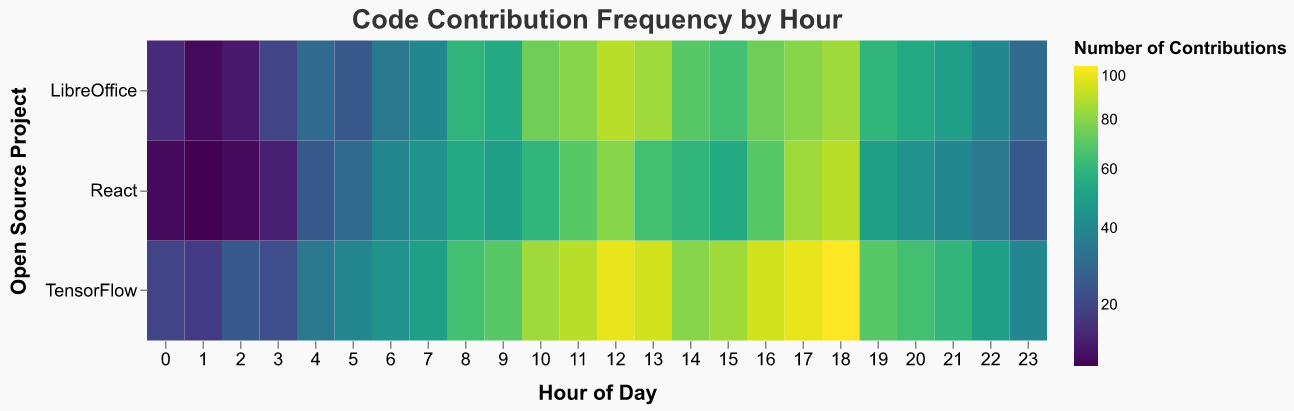What is the title of the heatmap? The title of the heatmap is displayed at the top of the visualization and generally provides an overview of what the chart represents.
Answer: Code Contribution Frequency by Hour Which project has the highest number of contributions at hour 12? To find this, locate hour 12 on the horizontal axis and compare the contributions for each project on the vertical axis. The color intensity helps identify the highest value.
Answer: TensorFlow At what hour does the React project have its peak number of contributions? Examine the row corresponding to 'React' by looking across different hours. Identify the hour with the most intense color, indicating the maximum contributions.
Answer: 18 How many data points are there in the heatmap? Each hour has an entry for all three projects, and there are 24 hours in a day. Multiply the number of projects by the number of hours. 3 projects * 24 hours = 72 data points.
Answer: 72 Which project tends to have the highest number of contributions throughout the day, on average? Compare the average color intensity across all hours for each project. The project with the most consistently intense colors will have the highest average contributions.
Answer: TensorFlow During which hours do all projects have relatively low contributions? Low contributions correspond to the least intense colors. Identify hours, such as early morning or late at night, where all projects show lower intensity colors.
Answer: 0-2 and 20-23 What is the difference in contributions for TensorFlow between hours 10 and 22? Find the contributions for TensorFlow at hour 10 (85) and at hour 22 (50). Calculate the difference: 85 - 50 = 35.
Answer: 35 Which hour has the highest combined contributions across all projects? Sum the contributions of all projects for each hour and identify the maximum sum. For example, hour 12 has contributions of LibreOffice (90) + TensorFlow (100) + React (80) = 270.
Answer: 12 Are there any hours where the contributions for all three projects are the same? Check all hours horizontally for uniform color intensity, indicating equal contributions. Contributions are not the same for all three projects at any hour.
Answer: No What trend do you observe in contributions for TensorFlow from hour 0 to hour 18? Starting at hour 0, observe the color intensity increase gradually for TensorFlow until reaching a peak at hour 18, indicating a rising trend in contributions.
Answer: Increasing trend 